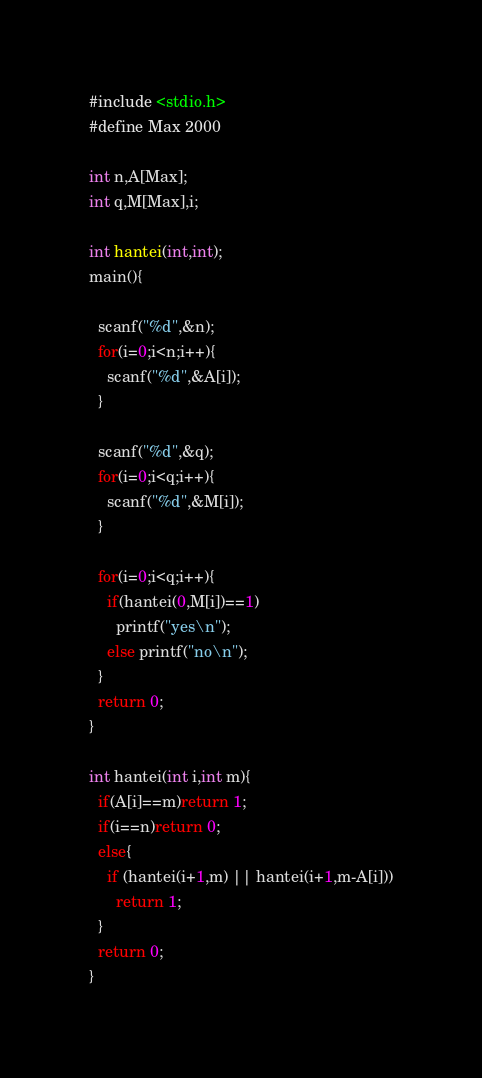Convert code to text. <code><loc_0><loc_0><loc_500><loc_500><_C_>#include <stdio.h>
#define Max 2000

int n,A[Max];
int q,M[Max],i;

int hantei(int,int);
main(){
  
  scanf("%d",&n);
  for(i=0;i<n;i++){
    scanf("%d",&A[i]);
  }
  
  scanf("%d",&q);
  for(i=0;i<q;i++){
    scanf("%d",&M[i]);
  }
  
  for(i=0;i<q;i++){
    if(hantei(0,M[i])==1)
      printf("yes\n");
    else printf("no\n");
  }
  return 0;
}

int hantei(int i,int m){
  if(A[i]==m)return 1;
  if(i==n)return 0;
  else{
    if (hantei(i+1,m) || hantei(i+1,m-A[i]))
      return 1;
  }
  return 0;
}</code> 